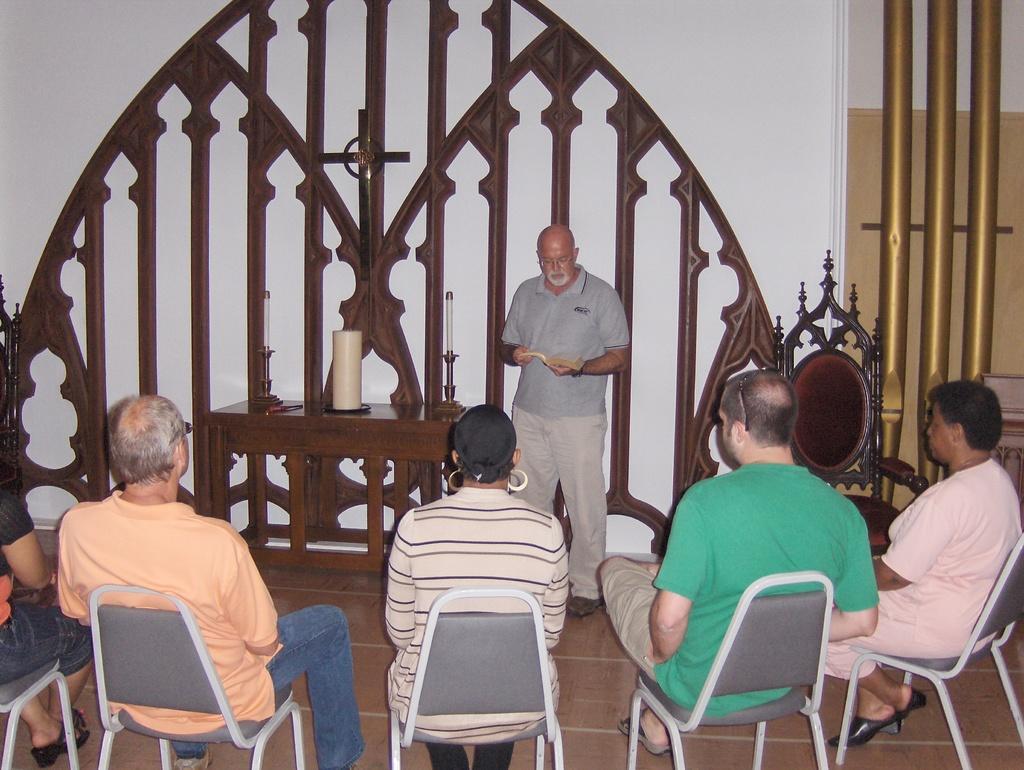Could you give a brief overview of what you see in this image? As we can see in the image there is a white color wall, few people sitting on chairs and there is a table. On table there are candles. 